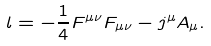<formula> <loc_0><loc_0><loc_500><loc_500>\L l = - \frac { 1 } { 4 } F ^ { \mu \nu } F _ { \mu \nu } - j ^ { \mu } A _ { \mu } .</formula> 